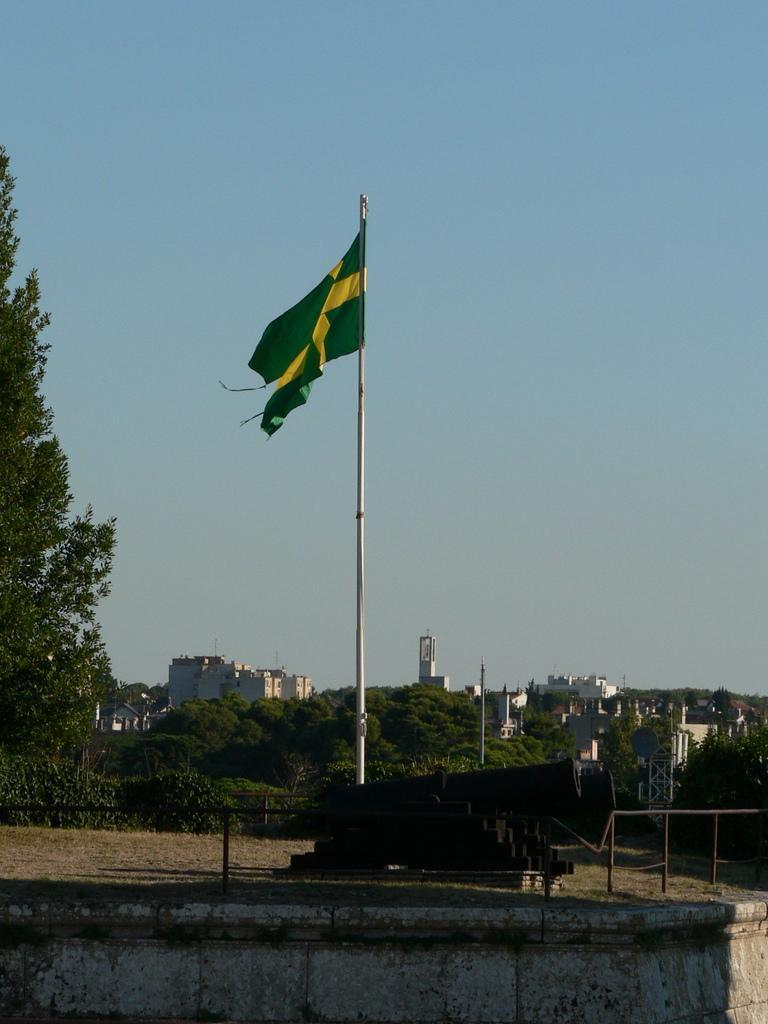In one or two sentences, can you explain what this image depicts? In the center of the image, we can see a flag and in the background, there are railings and we can see trees, buildings and poles. At the top, there is sky. 